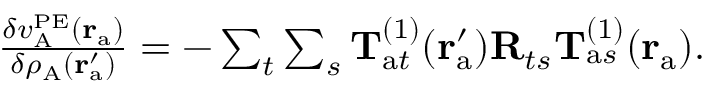Convert formula to latex. <formula><loc_0><loc_0><loc_500><loc_500>\begin{array} { r } { \frac { \delta v _ { A } ^ { P E } ( r _ { a } ) } { \delta \rho _ { A } ( r _ { a } ^ { \prime } ) } = - \sum _ { t } \sum _ { s } T _ { a t } ^ { ( 1 ) } ( r _ { a } ^ { \prime } ) R _ { t s } T _ { a s } ^ { ( 1 ) } ( r _ { a } ) . } \end{array}</formula> 